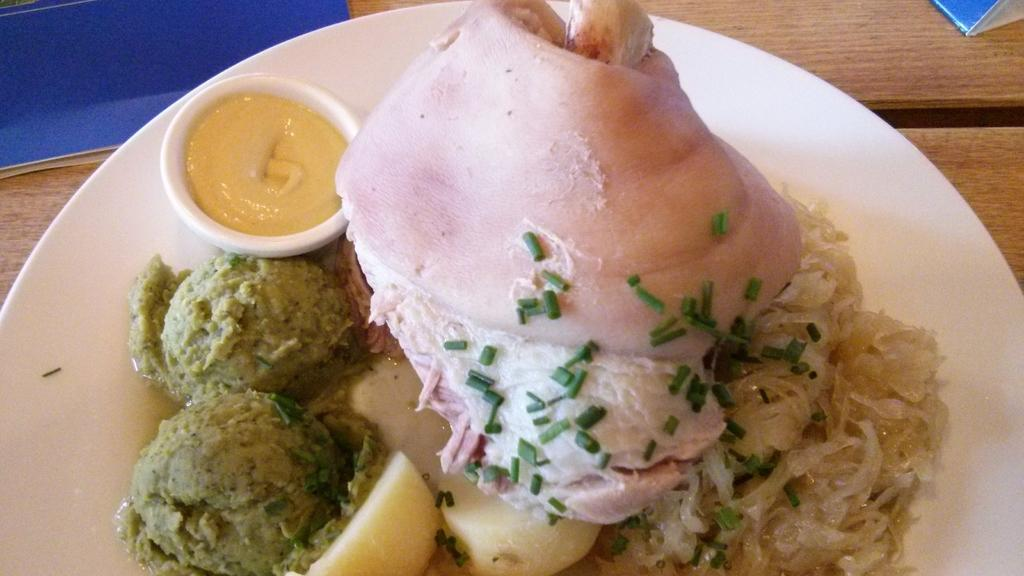What is on the plate in the image? There are food items on the plate in the image. What is in the bowl next to the plate? There is a bowl filled with sauce in the image. Can you describe the surface on which the plate and bowl might be placed? The plate and bowl may be on a table in the image. Where might this image have been taken? The image may have been taken in a hotel. What type of gun is being used for teaching in the image? There is no gun or teaching activity present in the image. 